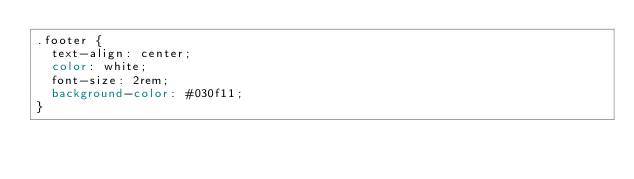Convert code to text. <code><loc_0><loc_0><loc_500><loc_500><_CSS_>.footer {
  text-align: center;
  color: white;
  font-size: 2rem;
  background-color: #030f11;
}
</code> 